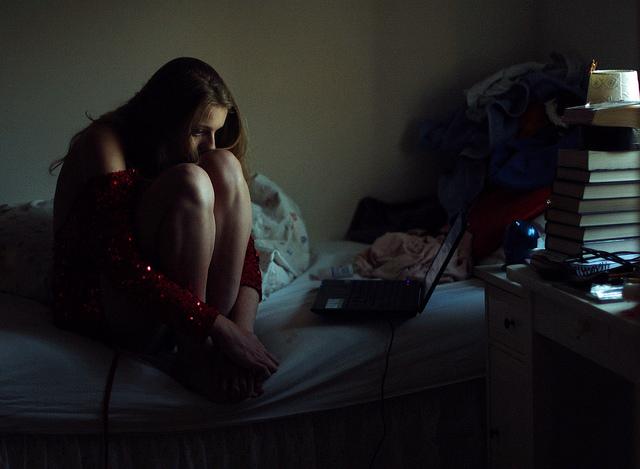How many white items are in the room?
Concise answer only. 4. Is this a fisheye lens photo?
Quick response, please. No. What is the woman's emotion?
Be succinct. Sad. What would lead you to believe she might be a student?
Be succinct. Books. How many computers are shown?
Be succinct. 1. 